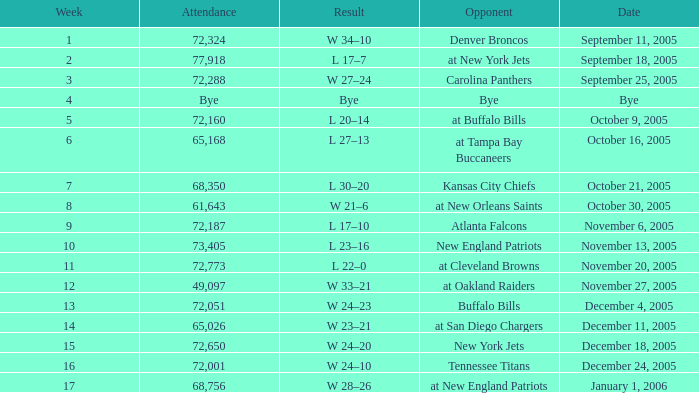On what Date was the Attendance 73,405? November 13, 2005. 